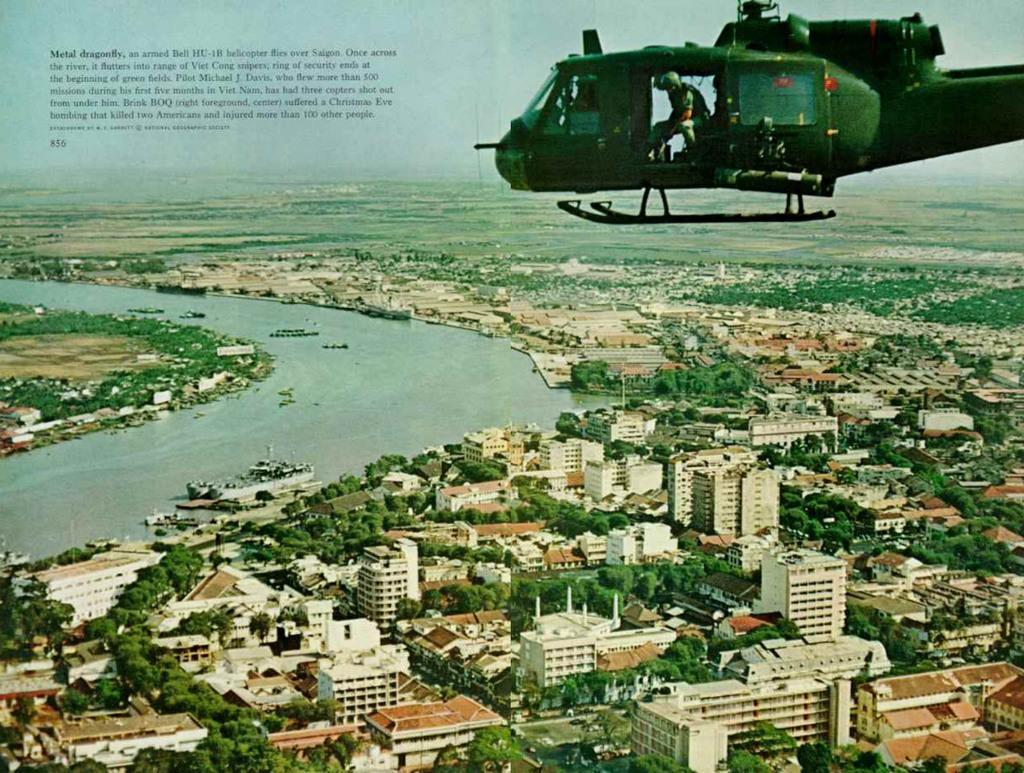Can you describe this image briefly? At the bottom of the picture, we see buildings and trees. Beside that, we see a water body. In the right top of the picture, we see a helicopter flying in the sky. We see a man riding the helicopter. In the left top of the picture, we see some text written. In the background, we see the sky. 